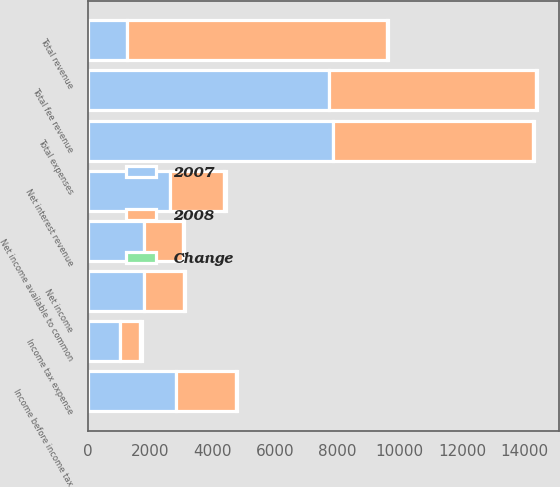<chart> <loc_0><loc_0><loc_500><loc_500><stacked_bar_chart><ecel><fcel>Total fee revenue<fcel>Net interest revenue<fcel>Total revenue<fcel>Total expenses<fcel>Income before income tax<fcel>Income tax expense<fcel>Net income<fcel>Net income available to common<nl><fcel>2007<fcel>7747<fcel>2650<fcel>1261<fcel>7851<fcel>2842<fcel>1031<fcel>1811<fcel>1789<nl><fcel>2008<fcel>6633<fcel>1730<fcel>8336<fcel>6433<fcel>1903<fcel>642<fcel>1261<fcel>1261<nl><fcel>Change<fcel>17<fcel>53<fcel>28<fcel>22<fcel>49<fcel>61<fcel>44<fcel>42<nl></chart> 